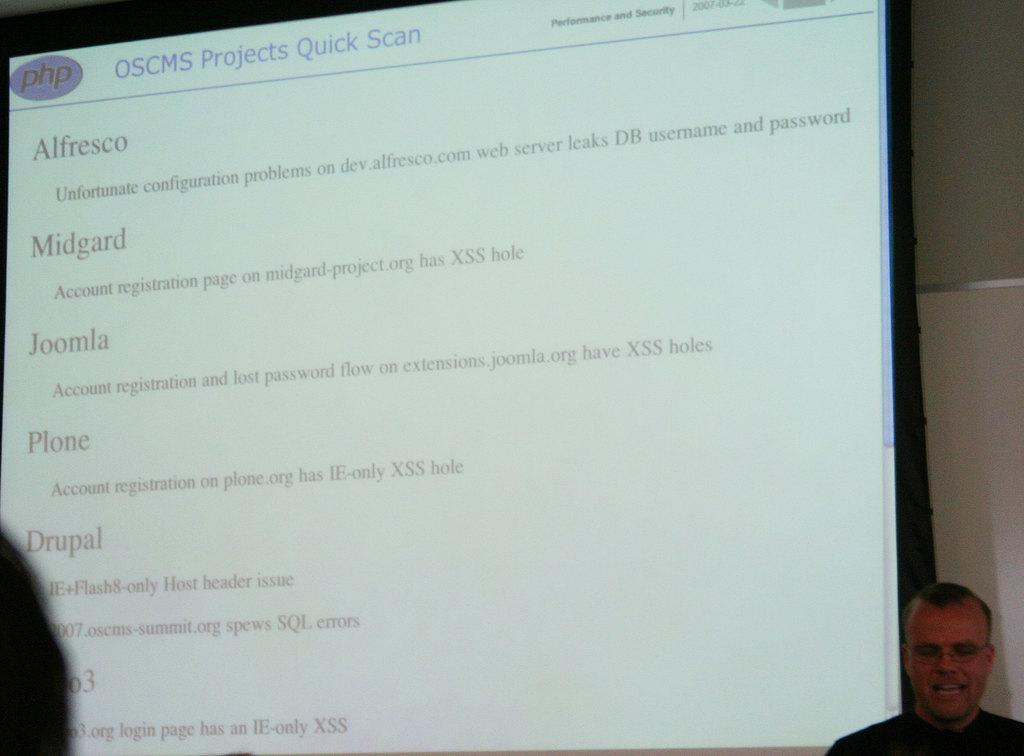What is the main object in the image? There is a presentation screen in the image. Who or what is near the presentation screen? There is a person beside the presentation screen. What can be seen behind the presentation screen? There is a wall behind the presentation screen. What type of van is parked next to the invention in the image? There is no van or invention present in the image; it only features a presentation screen and a person beside it. 